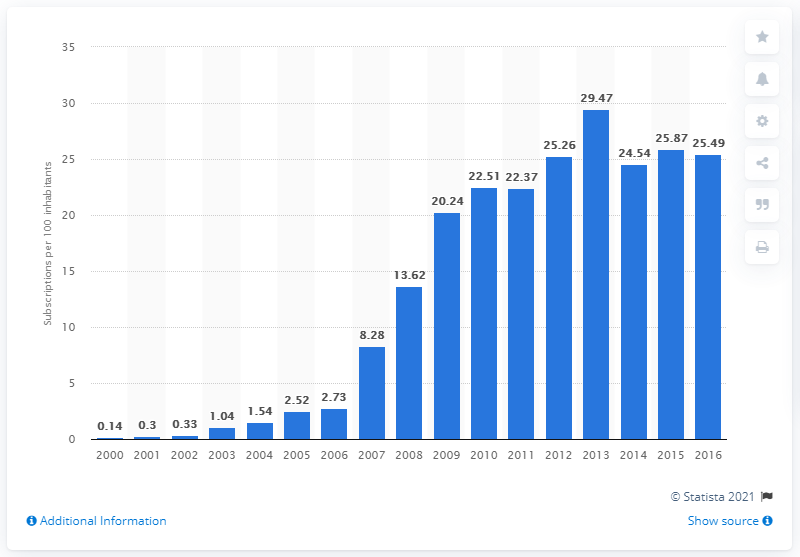Indicate a few pertinent items in this graphic. In the Central African Republic between 2000 and 2016, there were an average of 25.49 mobile cellular subscriptions for every 100 people. 